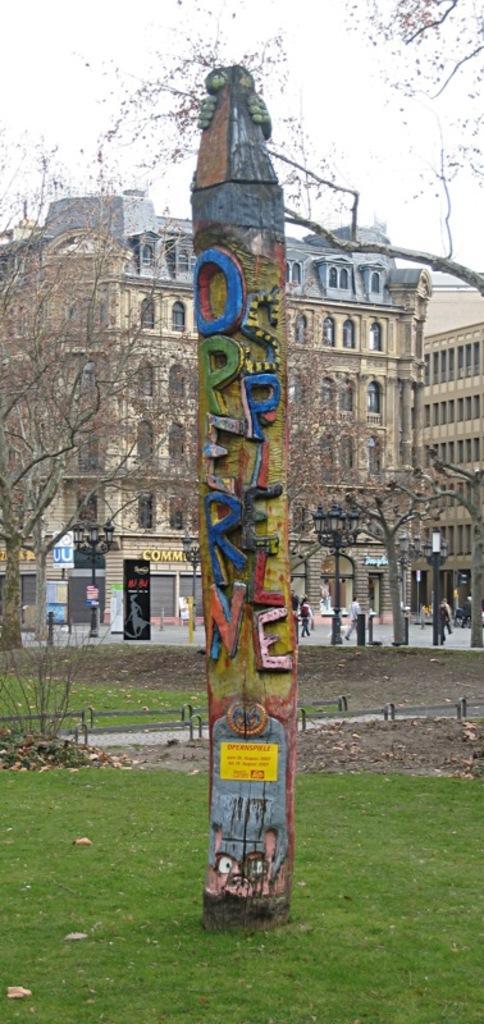In one or two sentences, can you explain what this image depicts? In this image we can see a visual arts to the pole at the foreground of the image and at the background of the image there are some trees, buildings and some persons walking on the ground and at the top of the image there is clear sky. 